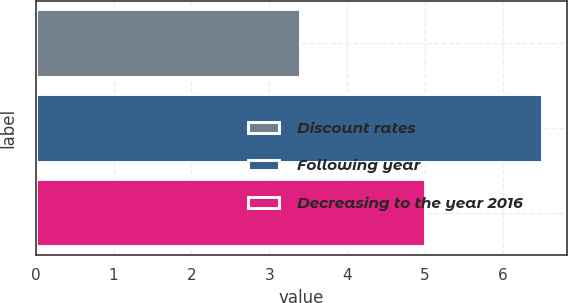Convert chart to OTSL. <chart><loc_0><loc_0><loc_500><loc_500><bar_chart><fcel>Discount rates<fcel>Following year<fcel>Decreasing to the year 2016<nl><fcel>3.4<fcel>6.5<fcel>5<nl></chart> 